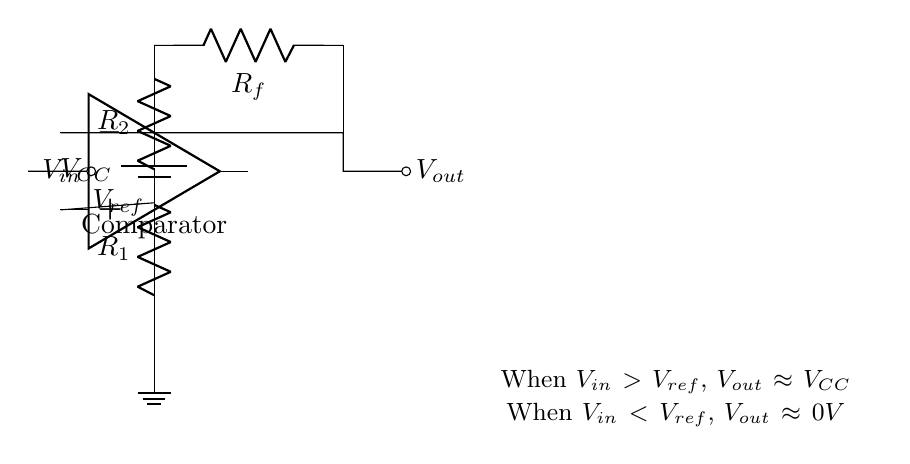What is the type of operational amplifier used in this circuit? The circuit includes a standard operational amplifier, generally used as a comparator. This can be identified by the two input terminals and the output that responds to the difference between the inputs.
Answer: Comparator What does the reference voltage represent? The reference voltage is represented at the terminal labeled V ref, and it serves as the threshold level against which the input voltage V in is compared in the operational amplifier.
Answer: Threshold level What happens to the output voltage when V in is greater than V ref? According to the provided explanation in the circuit, when V in exceeds V ref, the output will approximate V CC, which indicates the output goes high.
Answer: V CC How many resistors are present in this circuit? The circuit includes three resistors: R 1, R 2, and R f, which are used to set up the reference voltage and feedback mechanism for the operational amplifier.
Answer: Three What is the role of the feedback resistor R f? The feedback resistor R f connects the output back to the inverting input of the operational amplifier, providing negative feedback that stabilizes the output based on the comparison of input and reference voltages.
Answer: Negative feedback stabilization What is the expected output voltage when V in is less than V ref? The circuit states that when V in is lower than V ref, the output voltage approaches 0 volts, indicating that the comparator is in its low state.
Answer: 0 volts What can be inferred about the circuit’s application in sensor systems? The use of a comparator for threshold detection allows for precise switching actions to be carried out in sensor systems, indicating an efficient response to the input signal based on the defined reference voltage.
Answer: Precise threshold detection 